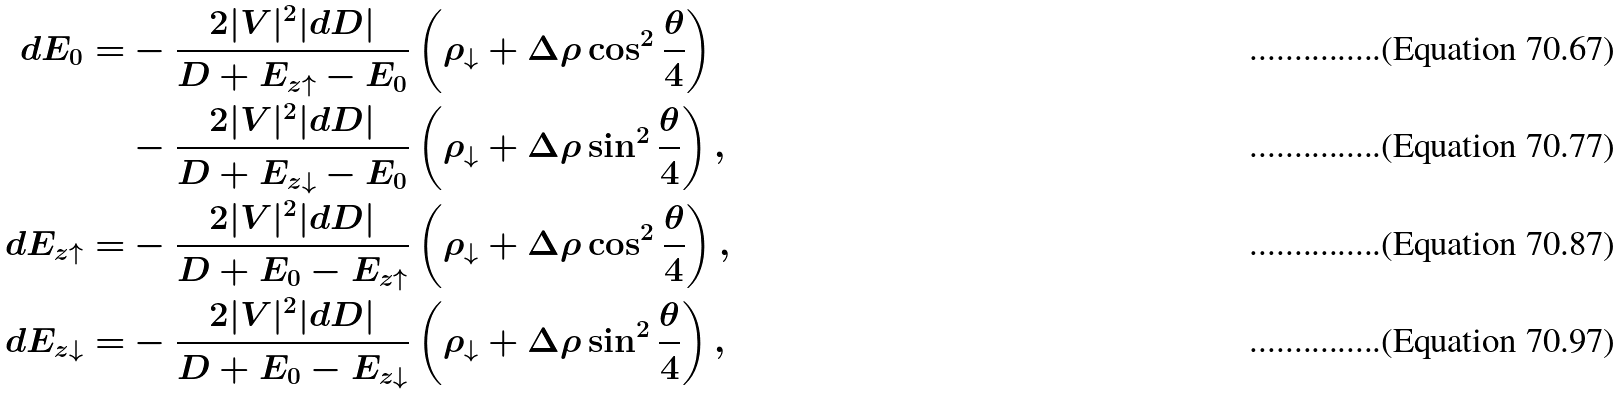Convert formula to latex. <formula><loc_0><loc_0><loc_500><loc_500>d E _ { 0 } = & - \frac { 2 | V | ^ { 2 } | d D | } { D + E _ { z \uparrow } - E _ { 0 } } \left ( \rho _ { \downarrow } + \Delta \rho \cos ^ { 2 } \frac { \theta } { 4 } \right ) \\ & - \frac { 2 | V | ^ { 2 } | d D | } { D + E _ { z \downarrow } - E _ { 0 } } \left ( \rho _ { \downarrow } + \Delta \rho \sin ^ { 2 } \frac { \theta } { 4 } \right ) , \\ d E _ { z \uparrow } = & - \frac { 2 | V | ^ { 2 } | d D | } { D + E _ { 0 } - E _ { z \uparrow } } \left ( \rho _ { \downarrow } + \Delta \rho \cos ^ { 2 } \frac { \theta } { 4 } \right ) , \\ d E _ { z \downarrow } = & - \frac { 2 | V | ^ { 2 } | d D | } { D + E _ { 0 } - E _ { z \downarrow } } \left ( \rho _ { \downarrow } + \Delta \rho \sin ^ { 2 } \frac { \theta } { 4 } \right ) ,</formula> 